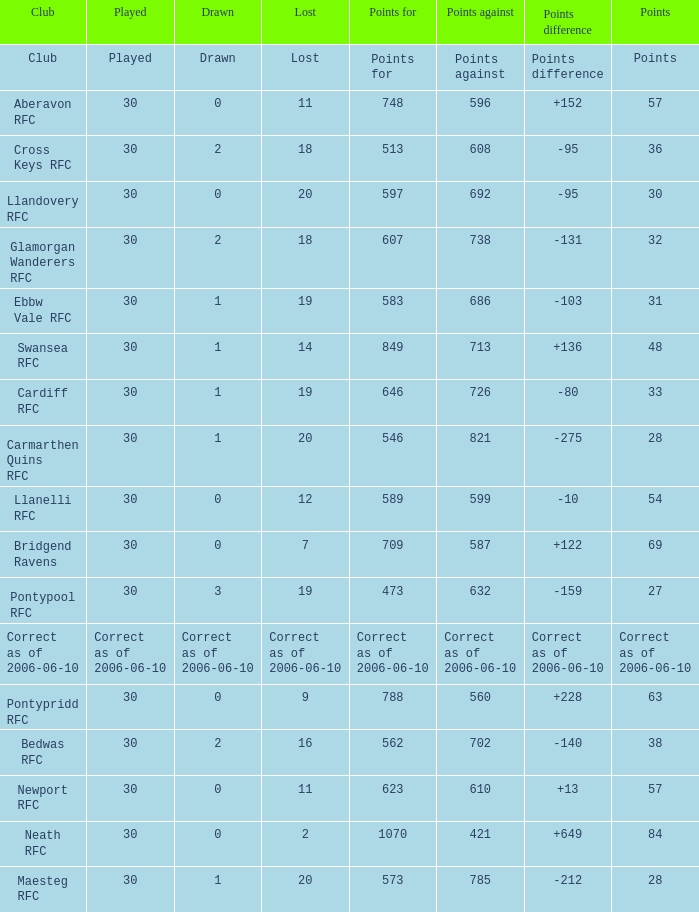What is Points Against, when Drawn is "2", and when Points Of is "32"? 738.0. 